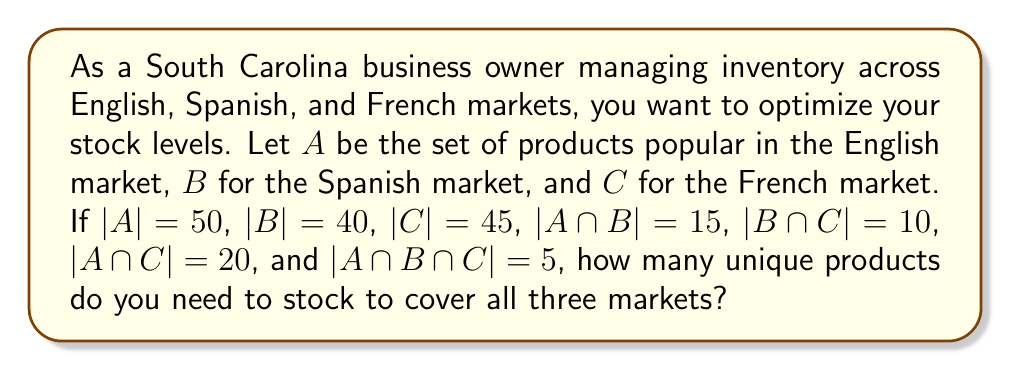Help me with this question. To solve this problem, we'll use the principle of inclusion-exclusion from set theory. The formula for the union of three sets is:

$$|A \cup B \cup C| = |A| + |B| + |C| - |A \cap B| - |B \cap C| - |A \cap C| + |A \cap B \cap C|$$

Let's substitute the given values:

1. $|A| = 50$
2. $|B| = 40$
3. $|C| = 45$
4. $|A \cap B| = 15$
5. $|B \cap C| = 10$
6. $|A \cap C| = 20$
7. $|A \cap B \cap C| = 5$

Now, let's calculate:

$$\begin{align*}
|A \cup B \cup C| &= 50 + 40 + 45 - 15 - 10 - 20 + 5 \\
&= 135 - 45 + 5 \\
&= 95
\end{align*}$$

This result represents the total number of unique products across all three markets.
Answer: 95 unique products 